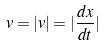Convert formula to latex. <formula><loc_0><loc_0><loc_500><loc_500>v = | v | = | \frac { d x } { d t } |</formula> 